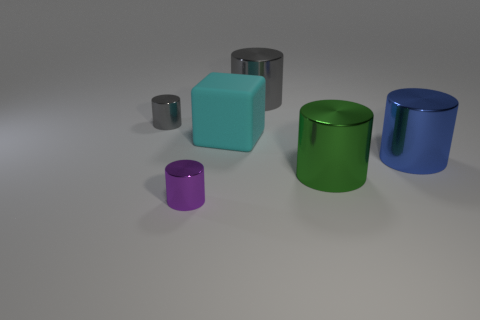What time of day or lighting conditions can be inferred from the shadows and lighting in the image? The shadows cast in the image suggest a singular, artificial light source positioned above and slightly to the front-left of the objects. There's no natural light evident, indicating the scene is likely indoors with controlled lighting, potentially simulating an overcast day or diffuse ambient light commonly found in studio settings. 